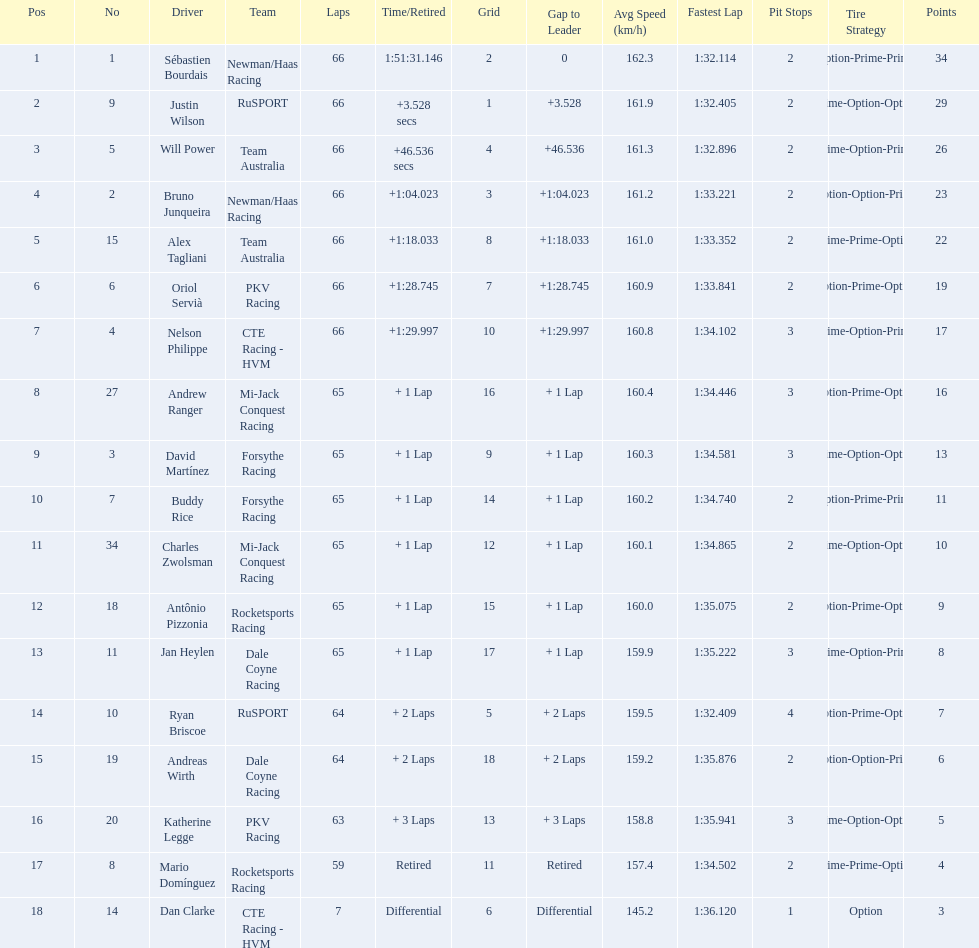Who are all of the 2006 gran premio telmex drivers? Sébastien Bourdais, Justin Wilson, Will Power, Bruno Junqueira, Alex Tagliani, Oriol Servià, Nelson Philippe, Andrew Ranger, David Martínez, Buddy Rice, Charles Zwolsman, Antônio Pizzonia, Jan Heylen, Ryan Briscoe, Andreas Wirth, Katherine Legge, Mario Domínguez, Dan Clarke. How many laps did they finish? 66, 66, 66, 66, 66, 66, 66, 65, 65, 65, 65, 65, 65, 64, 64, 63, 59, 7. What about just oriol servia and katherine legge? 66, 63. And which of those two drivers finished more laps? Oriol Servià. Could you help me parse every detail presented in this table? {'header': ['Pos', 'No', 'Driver', 'Team', 'Laps', 'Time/Retired', 'Grid', 'Gap to Leader', 'Avg Speed (km/h)', 'Fastest Lap', 'Pit Stops', 'Tire Strategy', 'Points'], 'rows': [['1', '1', 'Sébastien Bourdais', 'Newman/Haas Racing', '66', '1:51:31.146', '2', '0', '162.3', '1:32.114', '2', 'Option-Prime-Prime', '34'], ['2', '9', 'Justin Wilson', 'RuSPORT', '66', '+3.528 secs', '1', '+3.528', '161.9', '1:32.405', '2', 'Prime-Option-Option', '29'], ['3', '5', 'Will Power', 'Team Australia', '66', '+46.536 secs', '4', '+46.536', '161.3', '1:32.896', '2', 'Prime-Option-Prime', '26'], ['4', '2', 'Bruno Junqueira', 'Newman/Haas Racing', '66', '+1:04.023', '3', '+1:04.023', '161.2', '1:33.221', '2', 'Option-Option-Prime', '23'], ['5', '15', 'Alex Tagliani', 'Team Australia', '66', '+1:18.033', '8', '+1:18.033', '161.0', '1:33.352', '2', 'Prime-Prime-Option', '22'], ['6', '6', 'Oriol Servià', 'PKV Racing', '66', '+1:28.745', '7', '+1:28.745', '160.9', '1:33.841', '2', 'Option-Prime-Option', '19'], ['7', '4', 'Nelson Philippe', 'CTE Racing - HVM', '66', '+1:29.997', '10', '+1:29.997', '160.8', '1:34.102', '3', 'Prime-Option-Prime', '17'], ['8', '27', 'Andrew Ranger', 'Mi-Jack Conquest Racing', '65', '+ 1 Lap', '16', '+ 1 Lap', '160.4', '1:34.446', '3', 'Option-Prime-Option', '16'], ['9', '3', 'David Martínez', 'Forsythe Racing', '65', '+ 1 Lap', '9', '+ 1 Lap', '160.3', '1:34.581', '3', 'Prime-Option-Option', '13'], ['10', '7', 'Buddy Rice', 'Forsythe Racing', '65', '+ 1 Lap', '14', '+ 1 Lap', '160.2', '1:34.740', '2', 'Option-Prime-Prime', '11'], ['11', '34', 'Charles Zwolsman', 'Mi-Jack Conquest Racing', '65', '+ 1 Lap', '12', '+ 1 Lap', '160.1', '1:34.865', '2', 'Prime-Option-Option', '10'], ['12', '18', 'Antônio Pizzonia', 'Rocketsports Racing', '65', '+ 1 Lap', '15', '+ 1 Lap', '160.0', '1:35.075', '2', 'Option-Prime-Option', '9'], ['13', '11', 'Jan Heylen', 'Dale Coyne Racing', '65', '+ 1 Lap', '17', '+ 1 Lap', '159.9', '1:35.222', '3', 'Prime-Option-Prime', '8'], ['14', '10', 'Ryan Briscoe', 'RuSPORT', '64', '+ 2 Laps', '5', '+ 2 Laps', '159.5', '1:32.409', '4', 'Option-Prime-Option', '7'], ['15', '19', 'Andreas Wirth', 'Dale Coyne Racing', '64', '+ 2 Laps', '18', '+ 2 Laps', '159.2', '1:35.876', '2', 'Option-Option-Prime', '6'], ['16', '20', 'Katherine Legge', 'PKV Racing', '63', '+ 3 Laps', '13', '+ 3 Laps', '158.8', '1:35.941', '3', 'Prime-Option-Option', '5'], ['17', '8', 'Mario Domínguez', 'Rocketsports Racing', '59', 'Retired', '11', 'Retired', '157.4', '1:34.502', '2', 'Prime-Prime-Option', '4'], ['18', '14', 'Dan Clarke', 'CTE Racing - HVM', '7', 'Differential', '6', 'Differential', '145.2', '1:36.120', '1', 'Option', '3']]} Which drivers scored at least 10 points? Sébastien Bourdais, Justin Wilson, Will Power, Bruno Junqueira, Alex Tagliani, Oriol Servià, Nelson Philippe, Andrew Ranger, David Martínez, Buddy Rice, Charles Zwolsman. Of those drivers, which ones scored at least 20 points? Sébastien Bourdais, Justin Wilson, Will Power, Bruno Junqueira, Alex Tagliani. Of those 5, which driver scored the most points? Sébastien Bourdais. 